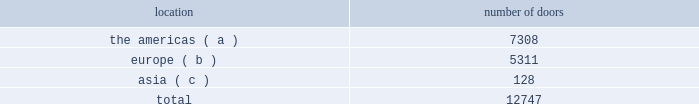Ralph lauren restaurants ralph lauren's restaurants translate mr .
Ralph lauren's distinctive vision into places to gather with family and friends to enjoy fine food .
In 1999 , the first rl restaurant opened , adjacent to the ralph lauren chicago store on michigan avenue .
This restaurant exemplifies the timeless design sensibility of ralph lauren's world and features classic american "city club" cuisine .
In 2010 , ralph's was opened in the courtyard and converted stables of our paris store on the blvd .
Saint germain .
Ralph's presents mr .
Lauren's favorite american classics in an elegant and glamorous french environment .
In august 2014 , we opened ralph's coffee on the second floor of our polo flagship store in new york city , featuring private custom coffee roasts , sandwiches , and sweet treats .
The polo bar , adjacent to our new york city polo flagship store , opened in january 2015 with a menu dedicated to serving seasonal american classics in a setting that pays homage to the sophisticated equestrian heritage of the ralph lauren world .
Our wholesale segment our wholesale segment sells our products globally to leading upscale and certain mid-tier department stores , specialty stores , and golf and pro shops .
We have continued to focus on elevating our brand by improving in-store product assortment and presentation , as well as full-price sell-throughs to consumers .
As of the end of fiscal 2015 , our wholesale products were sold through approximately 13000 doors worldwide and we invested $ 48 million of capital in related shop-within-shops during fiscal 2015 , primarily in domestic and international department and specialty stores .
Our products are also sold through the e-commerce sites of certain of our wholesale customers .
The primary product offerings sold through our wholesale channels of distribution include apparel , accessories , and home furnishings .
Our collection brands 2014 ralph lauren women's collection and black label and men's purple label and black label 2014 are distributed worldwide through a limited number of premier fashion retailers .
Department stores are our major wholesale customers in north america .
In latin america , our wholesale products are sold in department stores and specialty stores .
In europe , our wholesale sales are comprised of a varying mix of sales to both department stores and specialty stores , depending on the country .
In japan , our wholesale products are distributed primarily through shop-within-shops at premier and top-tier department stores .
In the greater china and southeast asia region , australia , and new zealand , our wholesale products are sold mainly at mid and top-tier department stores .
We also distribute our wholesale products to certain licensed stores operated by our partners in latin america , asia , europe , and the middle east .
We sell the majority of our excess and out-of-season products through secondary distribution channels worldwide , including our retail factory stores .
Worldwide wholesale distribution channels the table presents the number of doors by geographic location in which products distributed by our wholesale segment were sold to consumers in our primary channels of distribution as of march 28 , 2015: .
( a ) includes the u.s. , canada , and latin america .
( b ) includes the middle east .
( c ) includes australia and new zealand .
We have three key wholesale customers that generate significant sales volume .
During fiscal 2015 , sales to our largest wholesale customer , macy's , inc .
( "macy's" ) , accounted for approximately 12% ( 12 % ) and 26% ( 26 % ) of our total net revenues and total wholesale net revenues , respectively .
Further , during fiscal 2015 , sales to our three largest wholesale customers , including macy's , accounted for approximately 24% ( 24 % ) and 52% ( 52 % ) of our total net revenues and total wholesale net revenues , respectively. .
What percentage of the wholesale segment doors as of march 28 , 2015 where located in europe? 
Computations: (5311 / 12747)
Answer: 0.41665. 